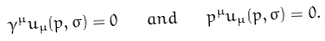<formula> <loc_0><loc_0><loc_500><loc_500>\gamma ^ { \mu } u _ { \mu } ( p , \sigma ) = 0 \quad a n d \quad p ^ { \mu } u _ { \mu } ( p , \sigma ) = 0 .</formula> 